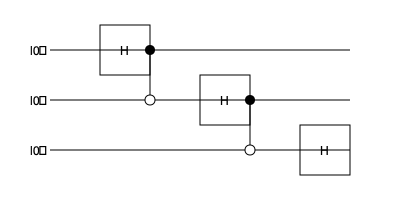Analyze the given quantum circuit diagram and determine its function. What is the resulting state of the three qubits after the circuit is executed, assuming perfect gates and no decoherence? Let's analyze this circuit step by step:

1. Initial state: All three qubits start in the $|0\rangle$ state. The initial state is $|000\rangle$.

2. First Hadamard gate (H):
   - Applied to the first qubit
   - Transforms $|0\rangle$ to $\frac{1}{\sqrt{2}}(|0\rangle + |1\rangle)$
   - State after this step: $\frac{1}{\sqrt{2}}(|0\rangle + |1\rangle) \otimes |00\rangle$

3. First CNOT gate:
   - Control qubit: first qubit
   - Target qubit: second qubit
   - If the first qubit is $|1\rangle$, it flips the second qubit
   - State after this step: $\frac{1}{\sqrt{2}}(|000\rangle + |110\rangle)$

4. Second Hadamard gate (H):
   - Applied to the second qubit
   - Transforms $|0\rangle$ to $\frac{1}{\sqrt{2}}(|0\rangle + |1\rangle)$ and $|1\rangle$ to $\frac{1}{\sqrt{2}}(|0\rangle - |1\rangle)$
   - State after this step: $\frac{1}{2}(|000\rangle + |001\rangle + |110\rangle - |111\rangle)$

5. Second CNOT gate:
   - Control qubit: second qubit
   - Target qubit: third qubit
   - If the second qubit is $|1\rangle$, it flips the third qubit
   - State after this step: $\frac{1}{2}(|000\rangle + |011\rangle + |110\rangle - |101\rangle)$

6. Third Hadamard gate (H):
   - Applied to the third qubit
   - Transforms $|0\rangle$ to $\frac{1}{\sqrt{2}}(|0\rangle + |1\rangle)$ and $|1\rangle$ to $\frac{1}{\sqrt{2}}(|0\rangle - |1\rangle)$
   - Final state: $\frac{1}{2\sqrt{2}}(|000\rangle + |001\rangle + |010\rangle - |011\rangle + |110\rangle + |111\rangle - |100\rangle + |101\rangle)$

This circuit creates a three-qubit entangled state known as the GHZ state (Greenberger-Horne-Zeilinger state).
Answer: $\frac{1}{2\sqrt{2}}(|000\rangle + |001\rangle + |010\rangle - |011\rangle + |110\rangle + |111\rangle - |100\rangle + |101\rangle)$ 